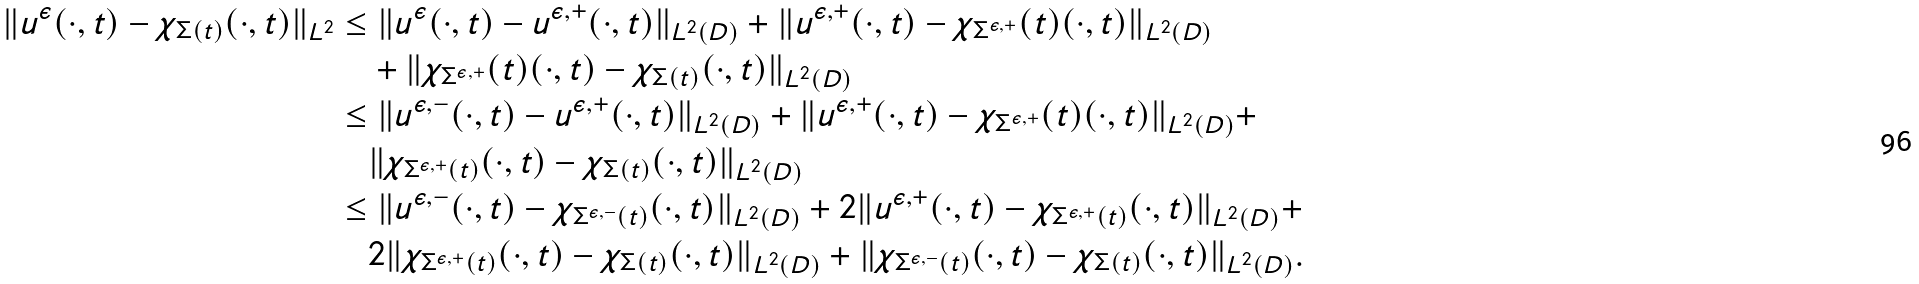Convert formula to latex. <formula><loc_0><loc_0><loc_500><loc_500>\| u ^ { \epsilon } ( \cdot , t ) - \chi _ { \Sigma ( t ) } ( \cdot , t ) \| _ { L ^ { 2 } } & \leq \| u ^ { \epsilon } ( \cdot , t ) - u ^ { \epsilon , + } ( \cdot , t ) \| _ { L ^ { 2 } ( D ) } + \| u ^ { \epsilon , + } ( \cdot , t ) - \chi _ { \Sigma ^ { \epsilon , + } } ( t ) ( \cdot , t ) \| _ { L ^ { 2 } ( D ) } \\ & \quad + \| \chi _ { \Sigma ^ { \epsilon , + } } ( t ) ( \cdot , t ) - \chi _ { \Sigma ( t ) } ( \cdot , t ) \| _ { L ^ { 2 } ( D ) } \\ & \leq \| u ^ { \epsilon , - } ( \cdot , t ) - u ^ { \epsilon , + } ( \cdot , t ) \| _ { L ^ { 2 } ( D ) } + \| u ^ { \epsilon , + } ( \cdot , t ) - \chi _ { \Sigma ^ { \epsilon , + } } ( t ) ( \cdot , t ) \| _ { L ^ { 2 } ( D ) } + \\ & \quad \| \chi _ { \Sigma ^ { \epsilon , + } ( t ) } ( \cdot , t ) - \chi _ { \Sigma ( t ) } ( \cdot , t ) \| _ { L ^ { 2 } ( D ) } \\ & \leq \| u ^ { \epsilon , - } ( \cdot , t ) - \chi _ { \Sigma ^ { \epsilon , - } ( t ) } ( \cdot , t ) \| _ { L ^ { 2 } ( D ) } + 2 \| u ^ { \epsilon , + } ( \cdot , t ) - \chi _ { \Sigma ^ { \epsilon , + } ( t ) } ( \cdot , t ) \| _ { L ^ { 2 } ( D ) } + \\ & \quad 2 \| \chi _ { \Sigma ^ { \epsilon , + } ( t ) } ( \cdot , t ) - \chi _ { \Sigma ( t ) } ( \cdot , t ) \| _ { L ^ { 2 } ( D ) } + \| \chi _ { \Sigma ^ { \epsilon , - } ( t ) } ( \cdot , t ) - \chi _ { \Sigma ( t ) } ( \cdot , t ) \| _ { L ^ { 2 } ( D ) } .</formula> 